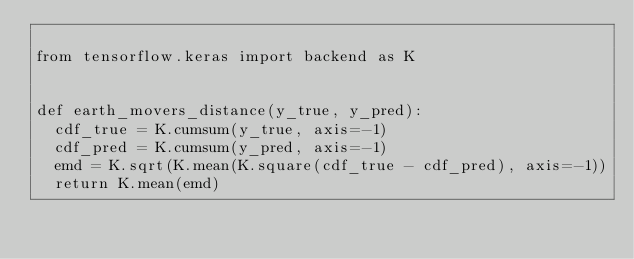<code> <loc_0><loc_0><loc_500><loc_500><_Python_>
from tensorflow.keras import backend as K


def earth_movers_distance(y_true, y_pred):
  cdf_true = K.cumsum(y_true, axis=-1)
  cdf_pred = K.cumsum(y_pred, axis=-1)
  emd = K.sqrt(K.mean(K.square(cdf_true - cdf_pred), axis=-1))
  return K.mean(emd)
</code> 